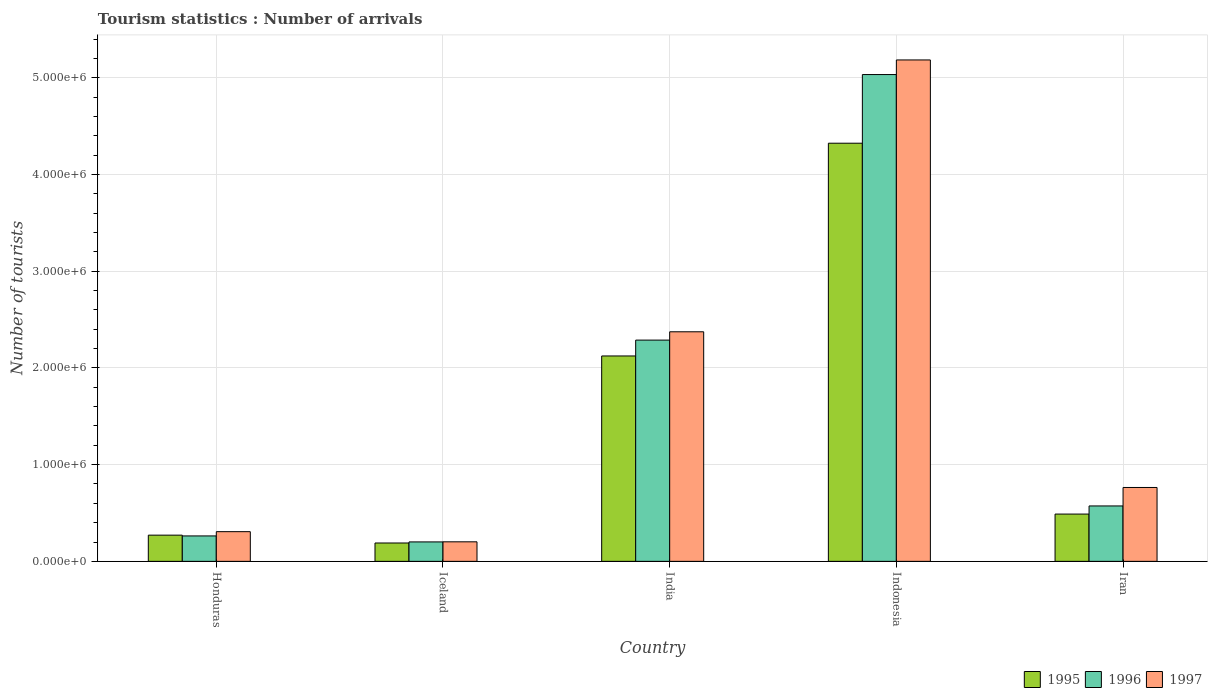How many different coloured bars are there?
Give a very brief answer. 3. How many groups of bars are there?
Offer a very short reply. 5. Are the number of bars per tick equal to the number of legend labels?
Your answer should be compact. Yes. How many bars are there on the 4th tick from the right?
Offer a terse response. 3. What is the label of the 2nd group of bars from the left?
Provide a succinct answer. Iceland. What is the number of tourist arrivals in 1996 in India?
Keep it short and to the point. 2.29e+06. Across all countries, what is the maximum number of tourist arrivals in 1996?
Provide a short and direct response. 5.03e+06. Across all countries, what is the minimum number of tourist arrivals in 1997?
Your response must be concise. 2.02e+05. In which country was the number of tourist arrivals in 1995 minimum?
Your answer should be compact. Iceland. What is the total number of tourist arrivals in 1996 in the graph?
Ensure brevity in your answer.  8.36e+06. What is the difference between the number of tourist arrivals in 1996 in India and that in Iran?
Provide a short and direct response. 1.72e+06. What is the difference between the number of tourist arrivals in 1997 in Indonesia and the number of tourist arrivals in 1995 in Honduras?
Make the answer very short. 4.91e+06. What is the average number of tourist arrivals in 1996 per country?
Provide a short and direct response. 1.67e+06. What is the difference between the number of tourist arrivals of/in 1997 and number of tourist arrivals of/in 1996 in Honduras?
Provide a short and direct response. 4.40e+04. In how many countries, is the number of tourist arrivals in 1995 greater than 1400000?
Provide a short and direct response. 2. What is the ratio of the number of tourist arrivals in 1995 in Honduras to that in Iceland?
Your response must be concise. 1.43. What is the difference between the highest and the second highest number of tourist arrivals in 1995?
Ensure brevity in your answer.  3.84e+06. What is the difference between the highest and the lowest number of tourist arrivals in 1995?
Keep it short and to the point. 4.13e+06. How many bars are there?
Make the answer very short. 15. How many countries are there in the graph?
Offer a very short reply. 5. Does the graph contain any zero values?
Provide a short and direct response. No. Does the graph contain grids?
Offer a terse response. Yes. Where does the legend appear in the graph?
Your answer should be very brief. Bottom right. How many legend labels are there?
Offer a terse response. 3. What is the title of the graph?
Ensure brevity in your answer.  Tourism statistics : Number of arrivals. Does "1998" appear as one of the legend labels in the graph?
Provide a short and direct response. No. What is the label or title of the Y-axis?
Provide a short and direct response. Number of tourists. What is the Number of tourists in 1995 in Honduras?
Your answer should be very brief. 2.71e+05. What is the Number of tourists in 1996 in Honduras?
Provide a succinct answer. 2.63e+05. What is the Number of tourists of 1997 in Honduras?
Ensure brevity in your answer.  3.07e+05. What is the Number of tourists in 1995 in Iceland?
Keep it short and to the point. 1.90e+05. What is the Number of tourists in 1996 in Iceland?
Your answer should be compact. 2.01e+05. What is the Number of tourists in 1997 in Iceland?
Keep it short and to the point. 2.02e+05. What is the Number of tourists in 1995 in India?
Provide a succinct answer. 2.12e+06. What is the Number of tourists of 1996 in India?
Ensure brevity in your answer.  2.29e+06. What is the Number of tourists of 1997 in India?
Your answer should be very brief. 2.37e+06. What is the Number of tourists of 1995 in Indonesia?
Make the answer very short. 4.32e+06. What is the Number of tourists in 1996 in Indonesia?
Your response must be concise. 5.03e+06. What is the Number of tourists of 1997 in Indonesia?
Provide a short and direct response. 5.18e+06. What is the Number of tourists of 1995 in Iran?
Keep it short and to the point. 4.89e+05. What is the Number of tourists in 1996 in Iran?
Offer a very short reply. 5.73e+05. What is the Number of tourists of 1997 in Iran?
Provide a short and direct response. 7.64e+05. Across all countries, what is the maximum Number of tourists in 1995?
Keep it short and to the point. 4.32e+06. Across all countries, what is the maximum Number of tourists of 1996?
Your response must be concise. 5.03e+06. Across all countries, what is the maximum Number of tourists of 1997?
Provide a short and direct response. 5.18e+06. Across all countries, what is the minimum Number of tourists in 1995?
Offer a terse response. 1.90e+05. Across all countries, what is the minimum Number of tourists in 1996?
Your answer should be very brief. 2.01e+05. Across all countries, what is the minimum Number of tourists of 1997?
Provide a succinct answer. 2.02e+05. What is the total Number of tourists in 1995 in the graph?
Offer a terse response. 7.40e+06. What is the total Number of tourists in 1996 in the graph?
Ensure brevity in your answer.  8.36e+06. What is the total Number of tourists in 1997 in the graph?
Make the answer very short. 8.83e+06. What is the difference between the Number of tourists of 1995 in Honduras and that in Iceland?
Your answer should be very brief. 8.10e+04. What is the difference between the Number of tourists of 1996 in Honduras and that in Iceland?
Provide a succinct answer. 6.20e+04. What is the difference between the Number of tourists of 1997 in Honduras and that in Iceland?
Ensure brevity in your answer.  1.05e+05. What is the difference between the Number of tourists of 1995 in Honduras and that in India?
Your response must be concise. -1.85e+06. What is the difference between the Number of tourists in 1996 in Honduras and that in India?
Keep it short and to the point. -2.02e+06. What is the difference between the Number of tourists of 1997 in Honduras and that in India?
Offer a terse response. -2.07e+06. What is the difference between the Number of tourists of 1995 in Honduras and that in Indonesia?
Offer a very short reply. -4.05e+06. What is the difference between the Number of tourists in 1996 in Honduras and that in Indonesia?
Ensure brevity in your answer.  -4.77e+06. What is the difference between the Number of tourists in 1997 in Honduras and that in Indonesia?
Your response must be concise. -4.88e+06. What is the difference between the Number of tourists of 1995 in Honduras and that in Iran?
Your answer should be compact. -2.18e+05. What is the difference between the Number of tourists in 1996 in Honduras and that in Iran?
Ensure brevity in your answer.  -3.10e+05. What is the difference between the Number of tourists in 1997 in Honduras and that in Iran?
Give a very brief answer. -4.57e+05. What is the difference between the Number of tourists of 1995 in Iceland and that in India?
Ensure brevity in your answer.  -1.93e+06. What is the difference between the Number of tourists in 1996 in Iceland and that in India?
Provide a succinct answer. -2.09e+06. What is the difference between the Number of tourists in 1997 in Iceland and that in India?
Provide a succinct answer. -2.17e+06. What is the difference between the Number of tourists in 1995 in Iceland and that in Indonesia?
Your answer should be very brief. -4.13e+06. What is the difference between the Number of tourists in 1996 in Iceland and that in Indonesia?
Offer a terse response. -4.83e+06. What is the difference between the Number of tourists in 1997 in Iceland and that in Indonesia?
Offer a very short reply. -4.98e+06. What is the difference between the Number of tourists of 1995 in Iceland and that in Iran?
Ensure brevity in your answer.  -2.99e+05. What is the difference between the Number of tourists of 1996 in Iceland and that in Iran?
Keep it short and to the point. -3.72e+05. What is the difference between the Number of tourists in 1997 in Iceland and that in Iran?
Offer a very short reply. -5.62e+05. What is the difference between the Number of tourists in 1995 in India and that in Indonesia?
Provide a short and direct response. -2.20e+06. What is the difference between the Number of tourists in 1996 in India and that in Indonesia?
Your answer should be very brief. -2.75e+06. What is the difference between the Number of tourists of 1997 in India and that in Indonesia?
Make the answer very short. -2.81e+06. What is the difference between the Number of tourists of 1995 in India and that in Iran?
Give a very brief answer. 1.64e+06. What is the difference between the Number of tourists of 1996 in India and that in Iran?
Your answer should be compact. 1.72e+06. What is the difference between the Number of tourists of 1997 in India and that in Iran?
Ensure brevity in your answer.  1.61e+06. What is the difference between the Number of tourists in 1995 in Indonesia and that in Iran?
Offer a very short reply. 3.84e+06. What is the difference between the Number of tourists in 1996 in Indonesia and that in Iran?
Provide a short and direct response. 4.46e+06. What is the difference between the Number of tourists of 1997 in Indonesia and that in Iran?
Make the answer very short. 4.42e+06. What is the difference between the Number of tourists in 1995 in Honduras and the Number of tourists in 1996 in Iceland?
Ensure brevity in your answer.  7.00e+04. What is the difference between the Number of tourists of 1995 in Honduras and the Number of tourists of 1997 in Iceland?
Provide a succinct answer. 6.90e+04. What is the difference between the Number of tourists of 1996 in Honduras and the Number of tourists of 1997 in Iceland?
Ensure brevity in your answer.  6.10e+04. What is the difference between the Number of tourists of 1995 in Honduras and the Number of tourists of 1996 in India?
Provide a short and direct response. -2.02e+06. What is the difference between the Number of tourists in 1995 in Honduras and the Number of tourists in 1997 in India?
Your answer should be very brief. -2.10e+06. What is the difference between the Number of tourists in 1996 in Honduras and the Number of tourists in 1997 in India?
Provide a short and direct response. -2.11e+06. What is the difference between the Number of tourists in 1995 in Honduras and the Number of tourists in 1996 in Indonesia?
Provide a succinct answer. -4.76e+06. What is the difference between the Number of tourists in 1995 in Honduras and the Number of tourists in 1997 in Indonesia?
Provide a short and direct response. -4.91e+06. What is the difference between the Number of tourists of 1996 in Honduras and the Number of tourists of 1997 in Indonesia?
Offer a very short reply. -4.92e+06. What is the difference between the Number of tourists in 1995 in Honduras and the Number of tourists in 1996 in Iran?
Give a very brief answer. -3.02e+05. What is the difference between the Number of tourists of 1995 in Honduras and the Number of tourists of 1997 in Iran?
Your answer should be compact. -4.93e+05. What is the difference between the Number of tourists in 1996 in Honduras and the Number of tourists in 1997 in Iran?
Keep it short and to the point. -5.01e+05. What is the difference between the Number of tourists of 1995 in Iceland and the Number of tourists of 1996 in India?
Offer a terse response. -2.10e+06. What is the difference between the Number of tourists of 1995 in Iceland and the Number of tourists of 1997 in India?
Ensure brevity in your answer.  -2.18e+06. What is the difference between the Number of tourists of 1996 in Iceland and the Number of tourists of 1997 in India?
Provide a short and direct response. -2.17e+06. What is the difference between the Number of tourists in 1995 in Iceland and the Number of tourists in 1996 in Indonesia?
Give a very brief answer. -4.84e+06. What is the difference between the Number of tourists of 1995 in Iceland and the Number of tourists of 1997 in Indonesia?
Make the answer very short. -5.00e+06. What is the difference between the Number of tourists of 1996 in Iceland and the Number of tourists of 1997 in Indonesia?
Your answer should be very brief. -4.98e+06. What is the difference between the Number of tourists of 1995 in Iceland and the Number of tourists of 1996 in Iran?
Offer a very short reply. -3.83e+05. What is the difference between the Number of tourists of 1995 in Iceland and the Number of tourists of 1997 in Iran?
Your answer should be compact. -5.74e+05. What is the difference between the Number of tourists of 1996 in Iceland and the Number of tourists of 1997 in Iran?
Offer a very short reply. -5.63e+05. What is the difference between the Number of tourists in 1995 in India and the Number of tourists in 1996 in Indonesia?
Provide a succinct answer. -2.91e+06. What is the difference between the Number of tourists in 1995 in India and the Number of tourists in 1997 in Indonesia?
Your response must be concise. -3.06e+06. What is the difference between the Number of tourists in 1996 in India and the Number of tourists in 1997 in Indonesia?
Keep it short and to the point. -2.90e+06. What is the difference between the Number of tourists in 1995 in India and the Number of tourists in 1996 in Iran?
Give a very brief answer. 1.55e+06. What is the difference between the Number of tourists in 1995 in India and the Number of tourists in 1997 in Iran?
Offer a very short reply. 1.36e+06. What is the difference between the Number of tourists of 1996 in India and the Number of tourists of 1997 in Iran?
Give a very brief answer. 1.52e+06. What is the difference between the Number of tourists of 1995 in Indonesia and the Number of tourists of 1996 in Iran?
Your answer should be compact. 3.75e+06. What is the difference between the Number of tourists in 1995 in Indonesia and the Number of tourists in 1997 in Iran?
Your answer should be compact. 3.56e+06. What is the difference between the Number of tourists of 1996 in Indonesia and the Number of tourists of 1997 in Iran?
Offer a very short reply. 4.27e+06. What is the average Number of tourists of 1995 per country?
Ensure brevity in your answer.  1.48e+06. What is the average Number of tourists in 1996 per country?
Keep it short and to the point. 1.67e+06. What is the average Number of tourists of 1997 per country?
Your answer should be compact. 1.77e+06. What is the difference between the Number of tourists of 1995 and Number of tourists of 1996 in Honduras?
Your response must be concise. 8000. What is the difference between the Number of tourists of 1995 and Number of tourists of 1997 in Honduras?
Provide a short and direct response. -3.60e+04. What is the difference between the Number of tourists of 1996 and Number of tourists of 1997 in Honduras?
Provide a succinct answer. -4.40e+04. What is the difference between the Number of tourists of 1995 and Number of tourists of 1996 in Iceland?
Provide a short and direct response. -1.10e+04. What is the difference between the Number of tourists in 1995 and Number of tourists in 1997 in Iceland?
Offer a very short reply. -1.20e+04. What is the difference between the Number of tourists in 1996 and Number of tourists in 1997 in Iceland?
Your answer should be compact. -1000. What is the difference between the Number of tourists in 1995 and Number of tourists in 1996 in India?
Ensure brevity in your answer.  -1.64e+05. What is the difference between the Number of tourists of 1995 and Number of tourists of 1997 in India?
Offer a very short reply. -2.50e+05. What is the difference between the Number of tourists in 1996 and Number of tourists in 1997 in India?
Provide a succinct answer. -8.60e+04. What is the difference between the Number of tourists of 1995 and Number of tourists of 1996 in Indonesia?
Provide a succinct answer. -7.10e+05. What is the difference between the Number of tourists of 1995 and Number of tourists of 1997 in Indonesia?
Provide a short and direct response. -8.61e+05. What is the difference between the Number of tourists of 1996 and Number of tourists of 1997 in Indonesia?
Your response must be concise. -1.51e+05. What is the difference between the Number of tourists of 1995 and Number of tourists of 1996 in Iran?
Provide a succinct answer. -8.40e+04. What is the difference between the Number of tourists of 1995 and Number of tourists of 1997 in Iran?
Give a very brief answer. -2.75e+05. What is the difference between the Number of tourists of 1996 and Number of tourists of 1997 in Iran?
Provide a short and direct response. -1.91e+05. What is the ratio of the Number of tourists in 1995 in Honduras to that in Iceland?
Your response must be concise. 1.43. What is the ratio of the Number of tourists of 1996 in Honduras to that in Iceland?
Provide a succinct answer. 1.31. What is the ratio of the Number of tourists of 1997 in Honduras to that in Iceland?
Your answer should be compact. 1.52. What is the ratio of the Number of tourists in 1995 in Honduras to that in India?
Offer a terse response. 0.13. What is the ratio of the Number of tourists in 1996 in Honduras to that in India?
Your answer should be compact. 0.11. What is the ratio of the Number of tourists in 1997 in Honduras to that in India?
Provide a succinct answer. 0.13. What is the ratio of the Number of tourists of 1995 in Honduras to that in Indonesia?
Keep it short and to the point. 0.06. What is the ratio of the Number of tourists in 1996 in Honduras to that in Indonesia?
Your answer should be very brief. 0.05. What is the ratio of the Number of tourists of 1997 in Honduras to that in Indonesia?
Your response must be concise. 0.06. What is the ratio of the Number of tourists in 1995 in Honduras to that in Iran?
Your answer should be very brief. 0.55. What is the ratio of the Number of tourists of 1996 in Honduras to that in Iran?
Keep it short and to the point. 0.46. What is the ratio of the Number of tourists in 1997 in Honduras to that in Iran?
Your response must be concise. 0.4. What is the ratio of the Number of tourists in 1995 in Iceland to that in India?
Your answer should be very brief. 0.09. What is the ratio of the Number of tourists in 1996 in Iceland to that in India?
Keep it short and to the point. 0.09. What is the ratio of the Number of tourists in 1997 in Iceland to that in India?
Provide a short and direct response. 0.09. What is the ratio of the Number of tourists in 1995 in Iceland to that in Indonesia?
Ensure brevity in your answer.  0.04. What is the ratio of the Number of tourists in 1996 in Iceland to that in Indonesia?
Provide a succinct answer. 0.04. What is the ratio of the Number of tourists in 1997 in Iceland to that in Indonesia?
Provide a succinct answer. 0.04. What is the ratio of the Number of tourists of 1995 in Iceland to that in Iran?
Your response must be concise. 0.39. What is the ratio of the Number of tourists of 1996 in Iceland to that in Iran?
Your answer should be very brief. 0.35. What is the ratio of the Number of tourists of 1997 in Iceland to that in Iran?
Your answer should be compact. 0.26. What is the ratio of the Number of tourists of 1995 in India to that in Indonesia?
Your answer should be very brief. 0.49. What is the ratio of the Number of tourists in 1996 in India to that in Indonesia?
Your response must be concise. 0.45. What is the ratio of the Number of tourists in 1997 in India to that in Indonesia?
Keep it short and to the point. 0.46. What is the ratio of the Number of tourists of 1995 in India to that in Iran?
Offer a very short reply. 4.34. What is the ratio of the Number of tourists in 1996 in India to that in Iran?
Give a very brief answer. 3.99. What is the ratio of the Number of tourists of 1997 in India to that in Iran?
Keep it short and to the point. 3.11. What is the ratio of the Number of tourists in 1995 in Indonesia to that in Iran?
Ensure brevity in your answer.  8.84. What is the ratio of the Number of tourists in 1996 in Indonesia to that in Iran?
Your response must be concise. 8.79. What is the ratio of the Number of tourists of 1997 in Indonesia to that in Iran?
Make the answer very short. 6.79. What is the difference between the highest and the second highest Number of tourists of 1995?
Make the answer very short. 2.20e+06. What is the difference between the highest and the second highest Number of tourists in 1996?
Your answer should be compact. 2.75e+06. What is the difference between the highest and the second highest Number of tourists in 1997?
Offer a terse response. 2.81e+06. What is the difference between the highest and the lowest Number of tourists in 1995?
Your answer should be compact. 4.13e+06. What is the difference between the highest and the lowest Number of tourists in 1996?
Ensure brevity in your answer.  4.83e+06. What is the difference between the highest and the lowest Number of tourists of 1997?
Provide a succinct answer. 4.98e+06. 